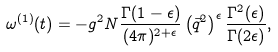<formula> <loc_0><loc_0><loc_500><loc_500>\omega ^ { ( 1 ) } ( t ) = - g ^ { 2 } N \frac { \Gamma ( 1 - \epsilon ) } { ( 4 \pi ) ^ { 2 + \epsilon } } \left ( \vec { q } ^ { 2 } \right ) ^ { \epsilon } \frac { \Gamma ^ { 2 } ( \epsilon ) } { \Gamma ( 2 \epsilon ) } ,</formula> 